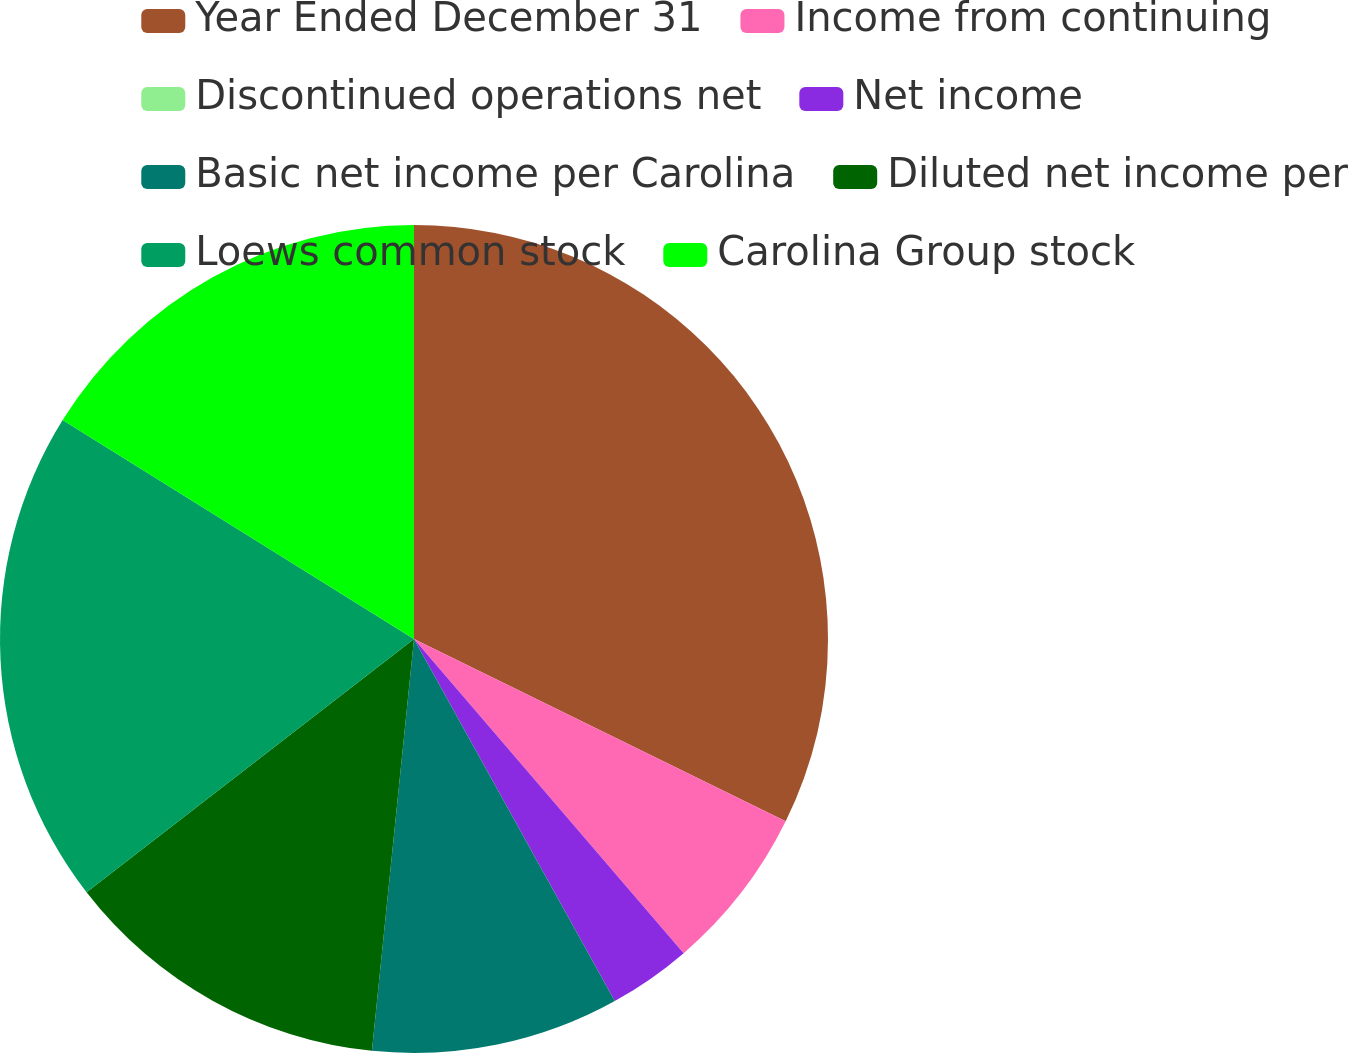<chart> <loc_0><loc_0><loc_500><loc_500><pie_chart><fcel>Year Ended December 31<fcel>Income from continuing<fcel>Discontinued operations net<fcel>Net income<fcel>Basic net income per Carolina<fcel>Diluted net income per<fcel>Loews common stock<fcel>Carolina Group stock<nl><fcel>32.26%<fcel>6.45%<fcel>0.0%<fcel>3.23%<fcel>9.68%<fcel>12.9%<fcel>19.35%<fcel>16.13%<nl></chart> 